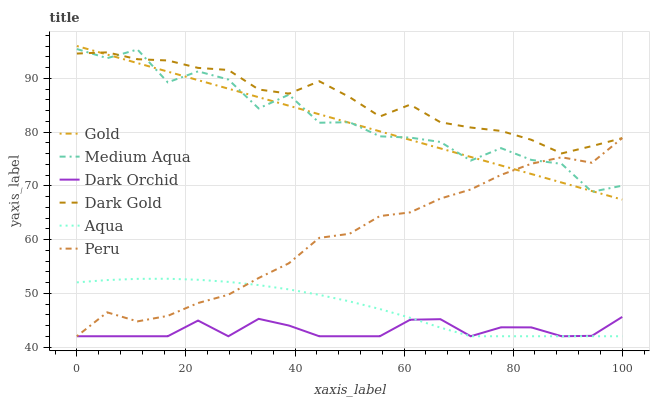Does Aqua have the minimum area under the curve?
Answer yes or no. No. Does Aqua have the maximum area under the curve?
Answer yes or no. No. Is Dark Gold the smoothest?
Answer yes or no. No. Is Dark Gold the roughest?
Answer yes or no. No. Does Dark Gold have the lowest value?
Answer yes or no. No. Does Dark Gold have the highest value?
Answer yes or no. No. Is Aqua less than Dark Gold?
Answer yes or no. Yes. Is Dark Gold greater than Dark Orchid?
Answer yes or no. Yes. Does Aqua intersect Dark Gold?
Answer yes or no. No. 